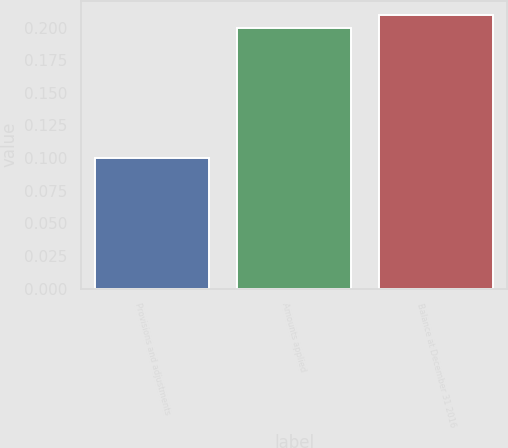Convert chart. <chart><loc_0><loc_0><loc_500><loc_500><bar_chart><fcel>Provisions and adjustments<fcel>Amounts applied<fcel>Balance at December 31 2016<nl><fcel>0.1<fcel>0.2<fcel>0.21<nl></chart> 